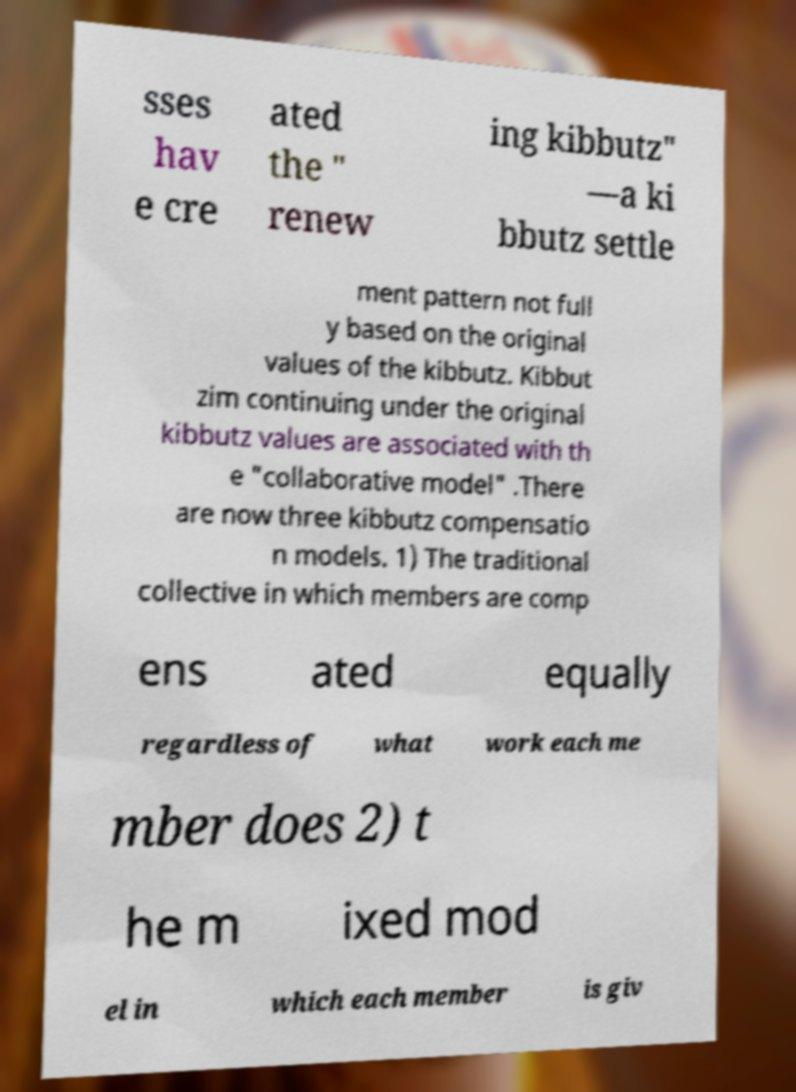Please identify and transcribe the text found in this image. sses hav e cre ated the " renew ing kibbutz" —a ki bbutz settle ment pattern not full y based on the original values of the kibbutz. Kibbut zim continuing under the original kibbutz values are associated with th e "collaborative model" .There are now three kibbutz compensatio n models. 1) The traditional collective in which members are comp ens ated equally regardless of what work each me mber does 2) t he m ixed mod el in which each member is giv 